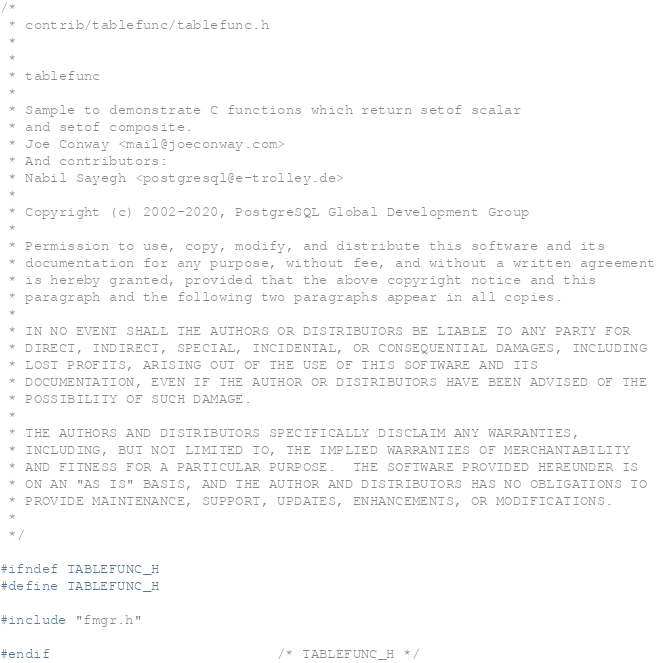Convert code to text. <code><loc_0><loc_0><loc_500><loc_500><_C_>/*
 * contrib/tablefunc/tablefunc.h
 *
 *
 * tablefunc
 *
 * Sample to demonstrate C functions which return setof scalar
 * and setof composite.
 * Joe Conway <mail@joeconway.com>
 * And contributors:
 * Nabil Sayegh <postgresql@e-trolley.de>
 *
 * Copyright (c) 2002-2020, PostgreSQL Global Development Group
 *
 * Permission to use, copy, modify, and distribute this software and its
 * documentation for any purpose, without fee, and without a written agreement
 * is hereby granted, provided that the above copyright notice and this
 * paragraph and the following two paragraphs appear in all copies.
 *
 * IN NO EVENT SHALL THE AUTHORS OR DISTRIBUTORS BE LIABLE TO ANY PARTY FOR
 * DIRECT, INDIRECT, SPECIAL, INCIDENTAL, OR CONSEQUENTIAL DAMAGES, INCLUDING
 * LOST PROFITS, ARISING OUT OF THE USE OF THIS SOFTWARE AND ITS
 * DOCUMENTATION, EVEN IF THE AUTHOR OR DISTRIBUTORS HAVE BEEN ADVISED OF THE
 * POSSIBILITY OF SUCH DAMAGE.
 *
 * THE AUTHORS AND DISTRIBUTORS SPECIFICALLY DISCLAIM ANY WARRANTIES,
 * INCLUDING, BUT NOT LIMITED TO, THE IMPLIED WARRANTIES OF MERCHANTABILITY
 * AND FITNESS FOR A PARTICULAR PURPOSE.  THE SOFTWARE PROVIDED HEREUNDER IS
 * ON AN "AS IS" BASIS, AND THE AUTHOR AND DISTRIBUTORS HAS NO OBLIGATIONS TO
 * PROVIDE MAINTENANCE, SUPPORT, UPDATES, ENHANCEMENTS, OR MODIFICATIONS.
 *
 */

#ifndef TABLEFUNC_H
#define TABLEFUNC_H

#include "fmgr.h"

#endif							/* TABLEFUNC_H */
</code> 